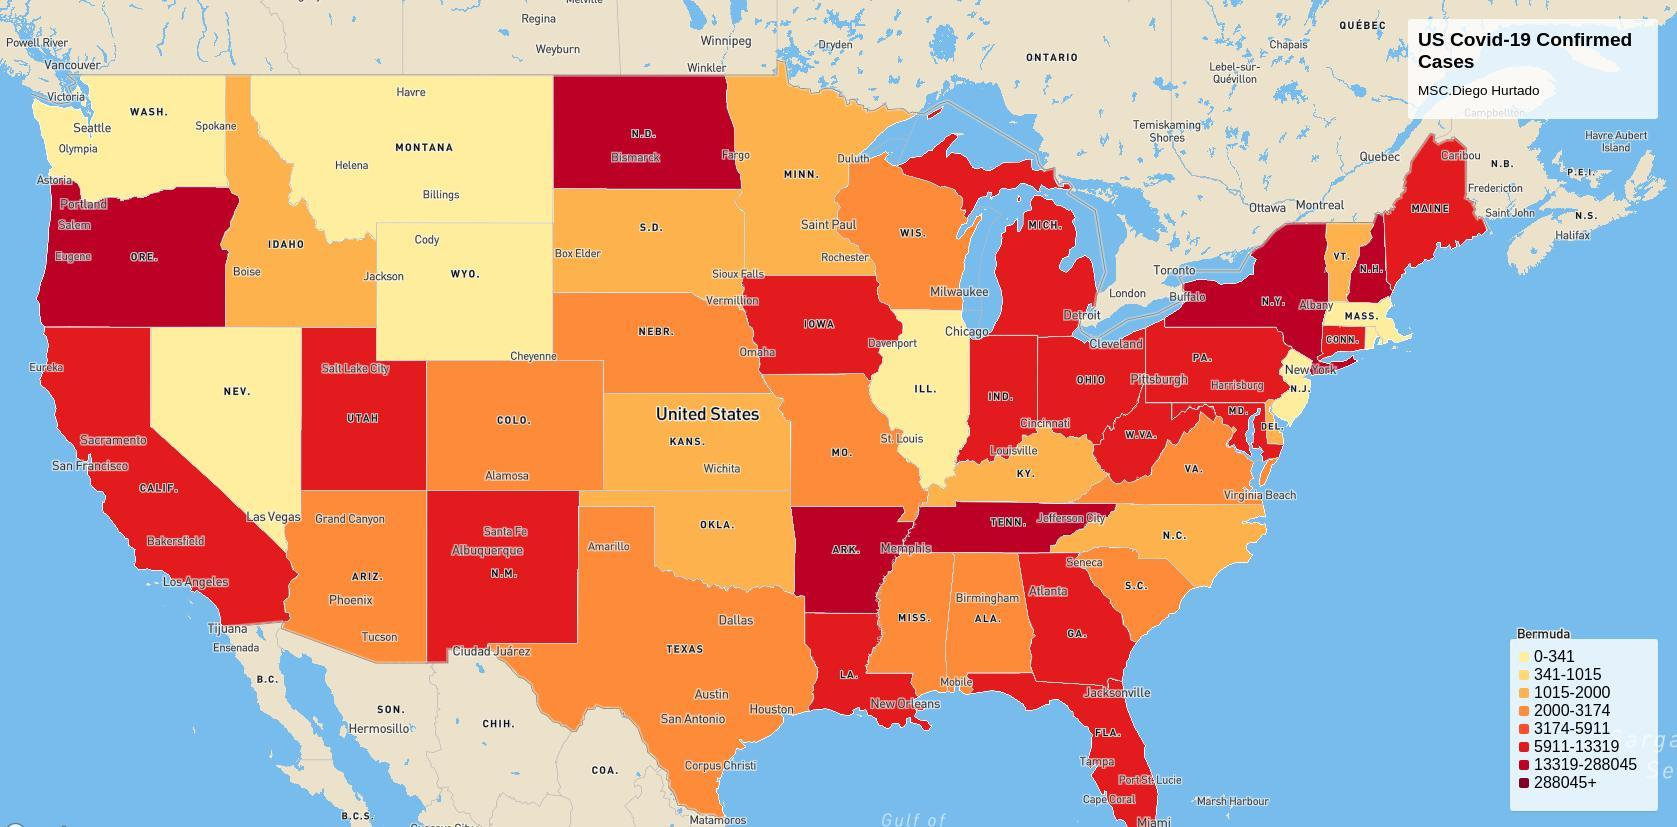What is the range of coronavirus in Washington?
Answer the question with a short phrase. 0-341 What is the range of coronavirus in Nevada? 0-341 What is the range of coronavirus in Montana? 0-341 What is the range of coronavirus in Atlanta? 3174-5911 What is the range of coronavirus in Texas? 2000-3174 